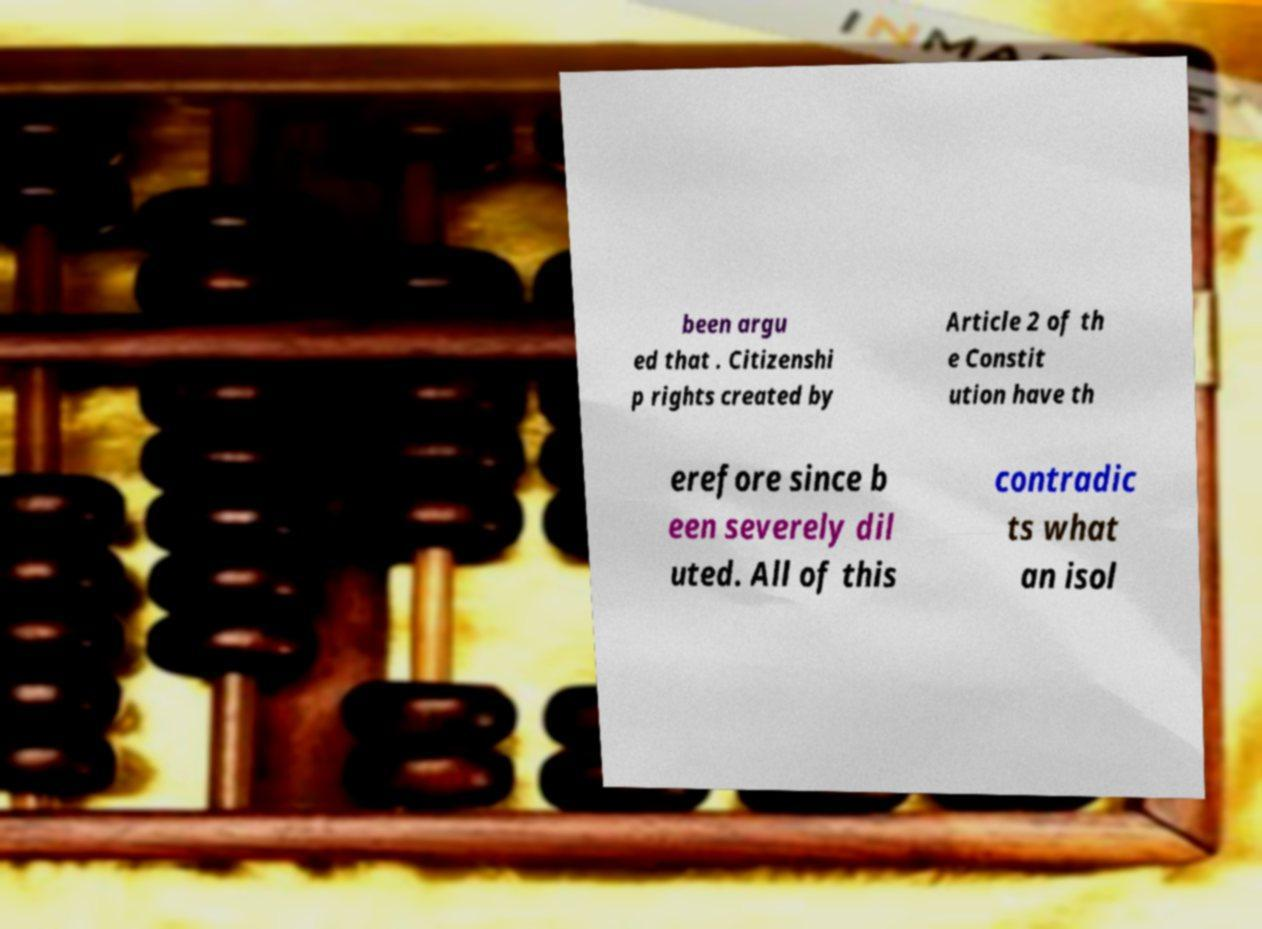What messages or text are displayed in this image? I need them in a readable, typed format. been argu ed that . Citizenshi p rights created by Article 2 of th e Constit ution have th erefore since b een severely dil uted. All of this contradic ts what an isol 